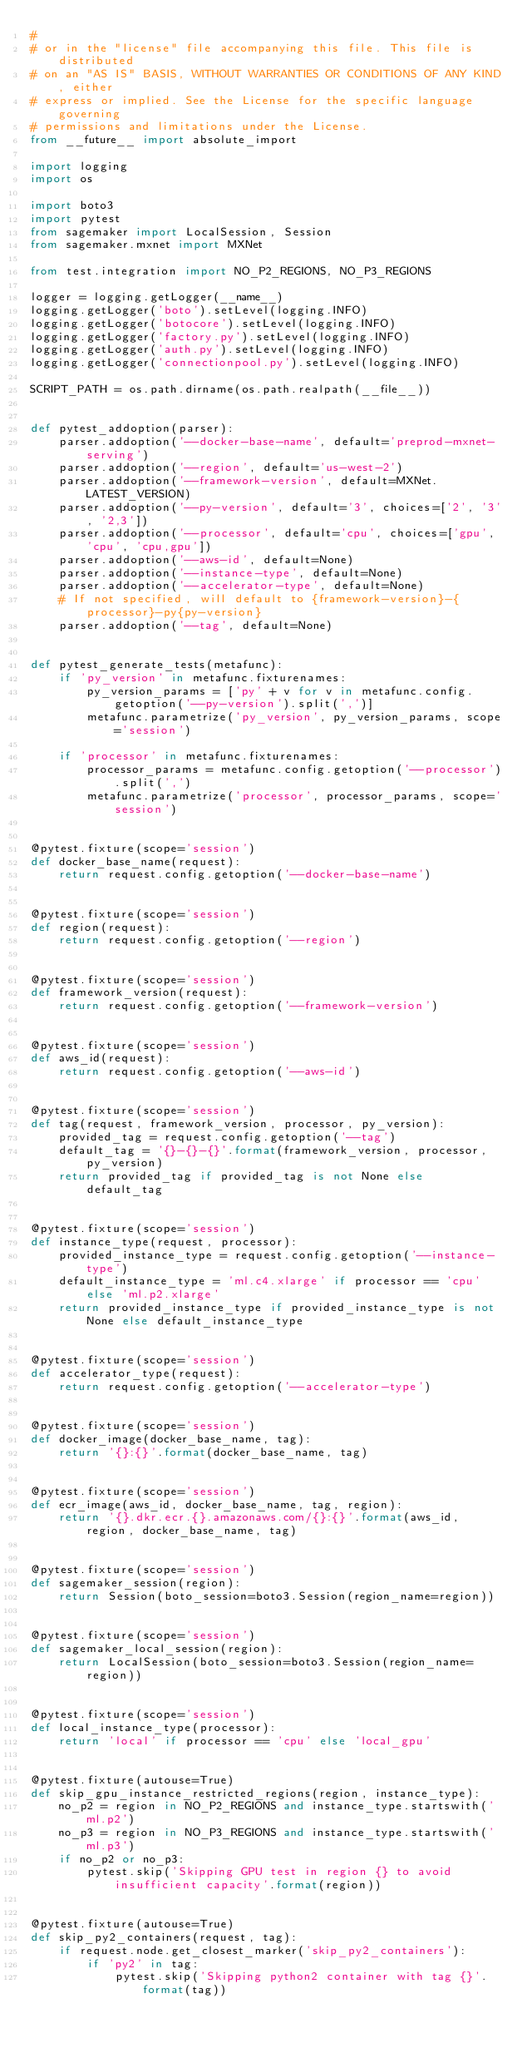<code> <loc_0><loc_0><loc_500><loc_500><_Python_>#
# or in the "license" file accompanying this file. This file is distributed
# on an "AS IS" BASIS, WITHOUT WARRANTIES OR CONDITIONS OF ANY KIND, either
# express or implied. See the License for the specific language governing
# permissions and limitations under the License.
from __future__ import absolute_import

import logging
import os

import boto3
import pytest
from sagemaker import LocalSession, Session
from sagemaker.mxnet import MXNet

from test.integration import NO_P2_REGIONS, NO_P3_REGIONS

logger = logging.getLogger(__name__)
logging.getLogger('boto').setLevel(logging.INFO)
logging.getLogger('botocore').setLevel(logging.INFO)
logging.getLogger('factory.py').setLevel(logging.INFO)
logging.getLogger('auth.py').setLevel(logging.INFO)
logging.getLogger('connectionpool.py').setLevel(logging.INFO)

SCRIPT_PATH = os.path.dirname(os.path.realpath(__file__))


def pytest_addoption(parser):
    parser.addoption('--docker-base-name', default='preprod-mxnet-serving')
    parser.addoption('--region', default='us-west-2')
    parser.addoption('--framework-version', default=MXNet.LATEST_VERSION)
    parser.addoption('--py-version', default='3', choices=['2', '3', '2,3'])
    parser.addoption('--processor', default='cpu', choices=['gpu', 'cpu', 'cpu,gpu'])
    parser.addoption('--aws-id', default=None)
    parser.addoption('--instance-type', default=None)
    parser.addoption('--accelerator-type', default=None)
    # If not specified, will default to {framework-version}-{processor}-py{py-version}
    parser.addoption('--tag', default=None)


def pytest_generate_tests(metafunc):
    if 'py_version' in metafunc.fixturenames:
        py_version_params = ['py' + v for v in metafunc.config.getoption('--py-version').split(',')]
        metafunc.parametrize('py_version', py_version_params, scope='session')

    if 'processor' in metafunc.fixturenames:
        processor_params = metafunc.config.getoption('--processor').split(',')
        metafunc.parametrize('processor', processor_params, scope='session')


@pytest.fixture(scope='session')
def docker_base_name(request):
    return request.config.getoption('--docker-base-name')


@pytest.fixture(scope='session')
def region(request):
    return request.config.getoption('--region')


@pytest.fixture(scope='session')
def framework_version(request):
    return request.config.getoption('--framework-version')


@pytest.fixture(scope='session')
def aws_id(request):
    return request.config.getoption('--aws-id')


@pytest.fixture(scope='session')
def tag(request, framework_version, processor, py_version):
    provided_tag = request.config.getoption('--tag')
    default_tag = '{}-{}-{}'.format(framework_version, processor, py_version)
    return provided_tag if provided_tag is not None else default_tag


@pytest.fixture(scope='session')
def instance_type(request, processor):
    provided_instance_type = request.config.getoption('--instance-type')
    default_instance_type = 'ml.c4.xlarge' if processor == 'cpu' else 'ml.p2.xlarge'
    return provided_instance_type if provided_instance_type is not None else default_instance_type


@pytest.fixture(scope='session')
def accelerator_type(request):
    return request.config.getoption('--accelerator-type')


@pytest.fixture(scope='session')
def docker_image(docker_base_name, tag):
    return '{}:{}'.format(docker_base_name, tag)


@pytest.fixture(scope='session')
def ecr_image(aws_id, docker_base_name, tag, region):
    return '{}.dkr.ecr.{}.amazonaws.com/{}:{}'.format(aws_id, region, docker_base_name, tag)


@pytest.fixture(scope='session')
def sagemaker_session(region):
    return Session(boto_session=boto3.Session(region_name=region))


@pytest.fixture(scope='session')
def sagemaker_local_session(region):
    return LocalSession(boto_session=boto3.Session(region_name=region))


@pytest.fixture(scope='session')
def local_instance_type(processor):
    return 'local' if processor == 'cpu' else 'local_gpu'


@pytest.fixture(autouse=True)
def skip_gpu_instance_restricted_regions(region, instance_type):
    no_p2 = region in NO_P2_REGIONS and instance_type.startswith('ml.p2')
    no_p3 = region in NO_P3_REGIONS and instance_type.startswith('ml.p3')
    if no_p2 or no_p3:
        pytest.skip('Skipping GPU test in region {} to avoid insufficient capacity'.format(region))


@pytest.fixture(autouse=True)
def skip_py2_containers(request, tag):
    if request.node.get_closest_marker('skip_py2_containers'):
        if 'py2' in tag:
            pytest.skip('Skipping python2 container with tag {}'.format(tag))
</code> 